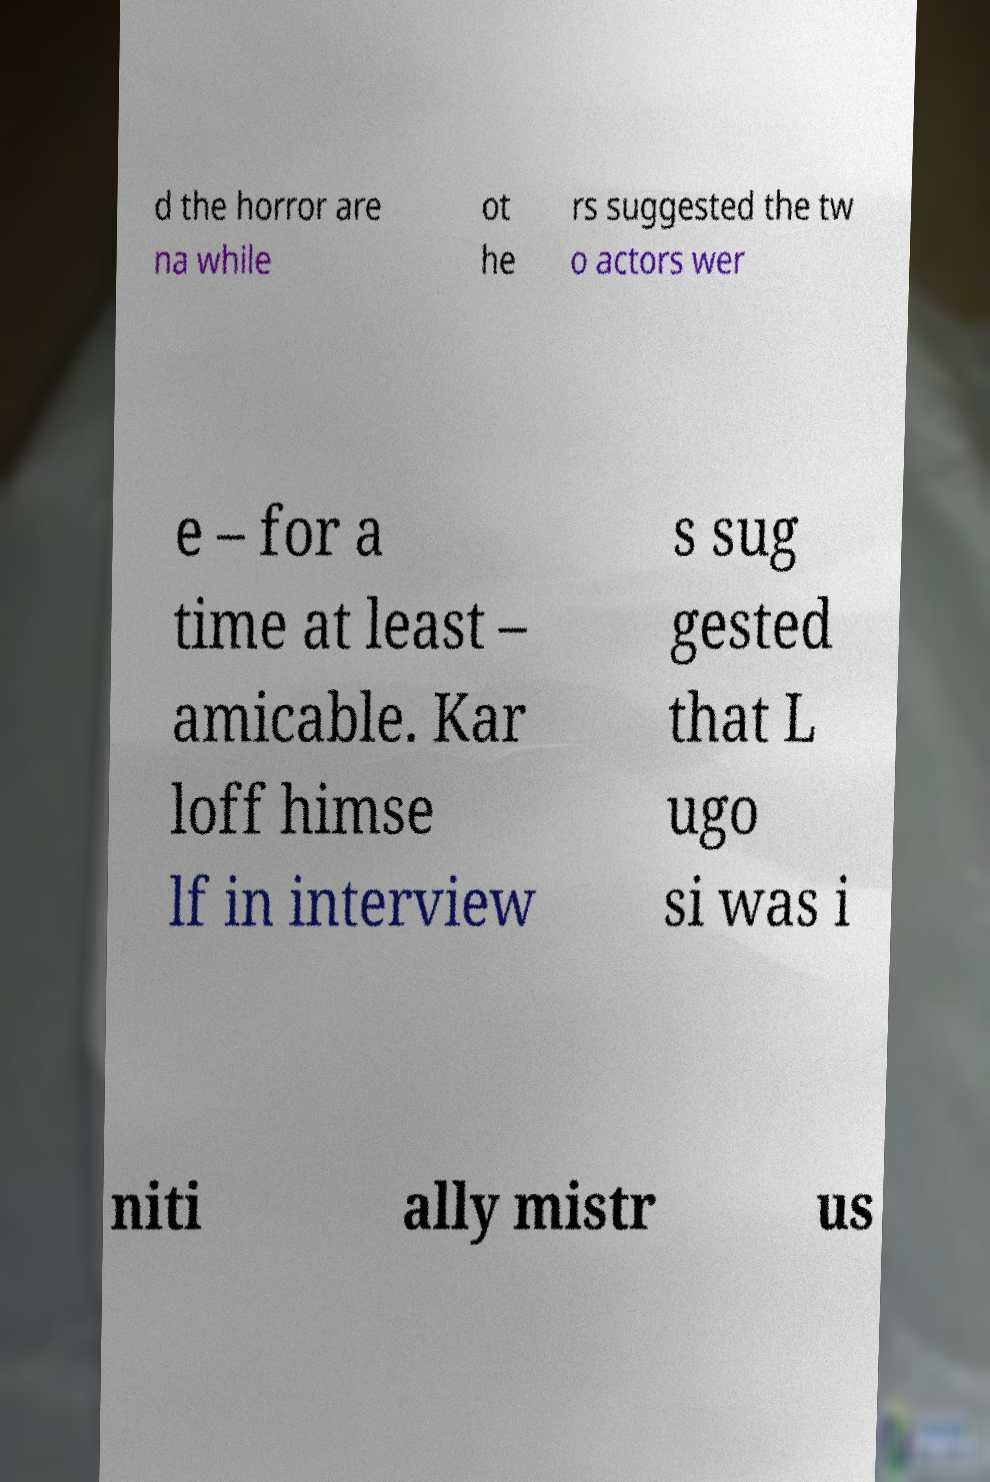What messages or text are displayed in this image? I need them in a readable, typed format. d the horror are na while ot he rs suggested the tw o actors wer e – for a time at least – amicable. Kar loff himse lf in interview s sug gested that L ugo si was i niti ally mistr us 